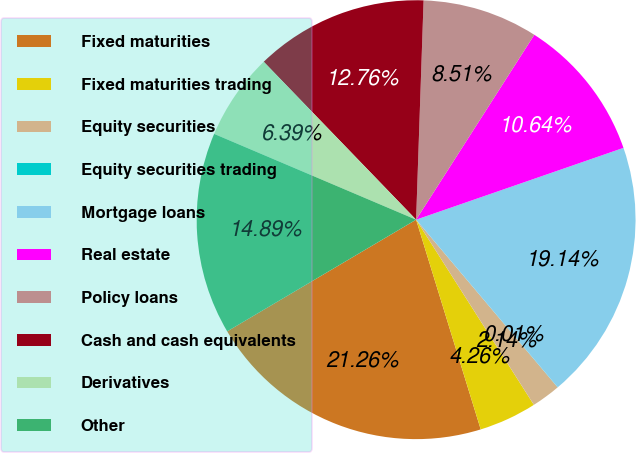Convert chart to OTSL. <chart><loc_0><loc_0><loc_500><loc_500><pie_chart><fcel>Fixed maturities<fcel>Fixed maturities trading<fcel>Equity securities<fcel>Equity securities trading<fcel>Mortgage loans<fcel>Real estate<fcel>Policy loans<fcel>Cash and cash equivalents<fcel>Derivatives<fcel>Other<nl><fcel>21.26%<fcel>4.26%<fcel>2.14%<fcel>0.01%<fcel>19.14%<fcel>10.64%<fcel>8.51%<fcel>12.76%<fcel>6.39%<fcel>14.89%<nl></chart> 